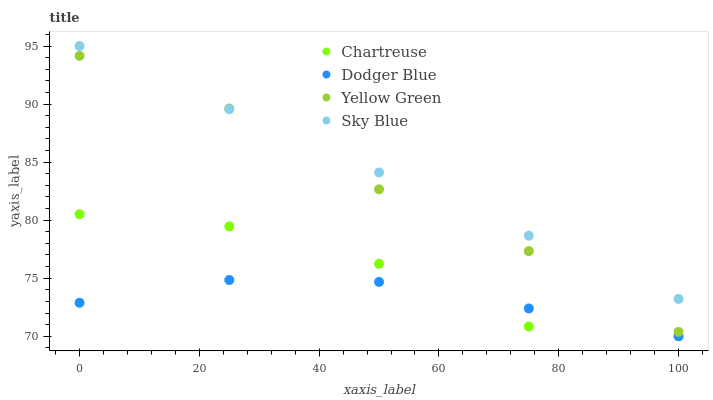Does Dodger Blue have the minimum area under the curve?
Answer yes or no. Yes. Does Sky Blue have the maximum area under the curve?
Answer yes or no. Yes. Does Chartreuse have the minimum area under the curve?
Answer yes or no. No. Does Chartreuse have the maximum area under the curve?
Answer yes or no. No. Is Sky Blue the smoothest?
Answer yes or no. Yes. Is Chartreuse the roughest?
Answer yes or no. Yes. Is Dodger Blue the smoothest?
Answer yes or no. No. Is Dodger Blue the roughest?
Answer yes or no. No. Does Chartreuse have the lowest value?
Answer yes or no. Yes. Does Yellow Green have the lowest value?
Answer yes or no. No. Does Sky Blue have the highest value?
Answer yes or no. Yes. Does Chartreuse have the highest value?
Answer yes or no. No. Is Dodger Blue less than Yellow Green?
Answer yes or no. Yes. Is Sky Blue greater than Dodger Blue?
Answer yes or no. Yes. Does Yellow Green intersect Sky Blue?
Answer yes or no. Yes. Is Yellow Green less than Sky Blue?
Answer yes or no. No. Is Yellow Green greater than Sky Blue?
Answer yes or no. No. Does Dodger Blue intersect Yellow Green?
Answer yes or no. No. 